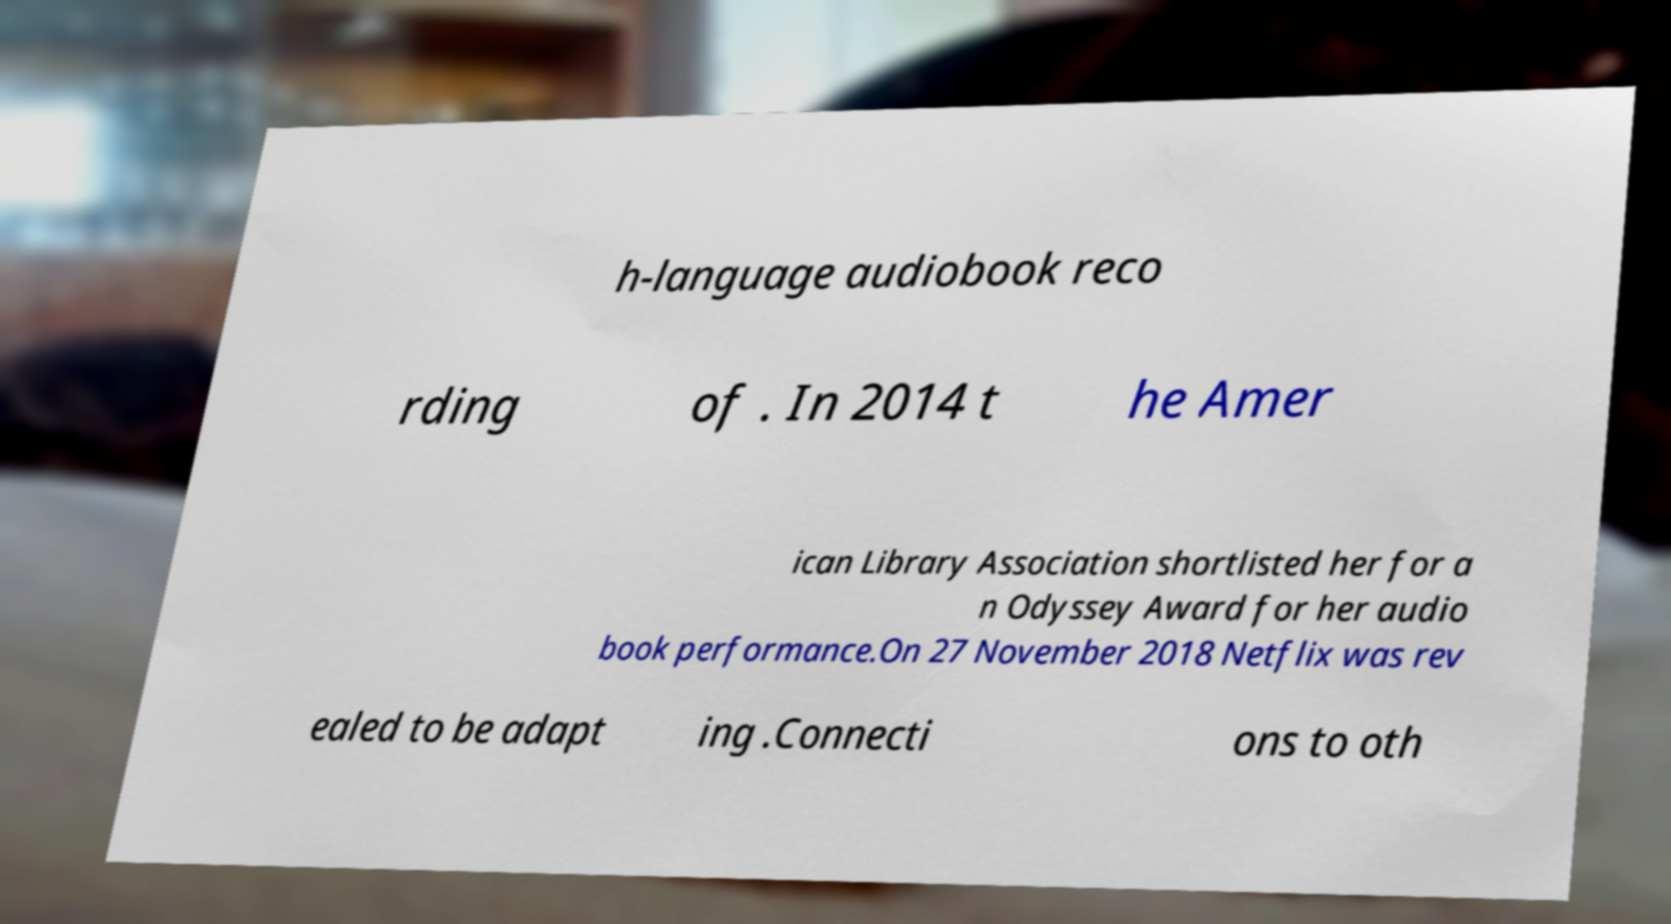There's text embedded in this image that I need extracted. Can you transcribe it verbatim? h-language audiobook reco rding of . In 2014 t he Amer ican Library Association shortlisted her for a n Odyssey Award for her audio book performance.On 27 November 2018 Netflix was rev ealed to be adapt ing .Connecti ons to oth 